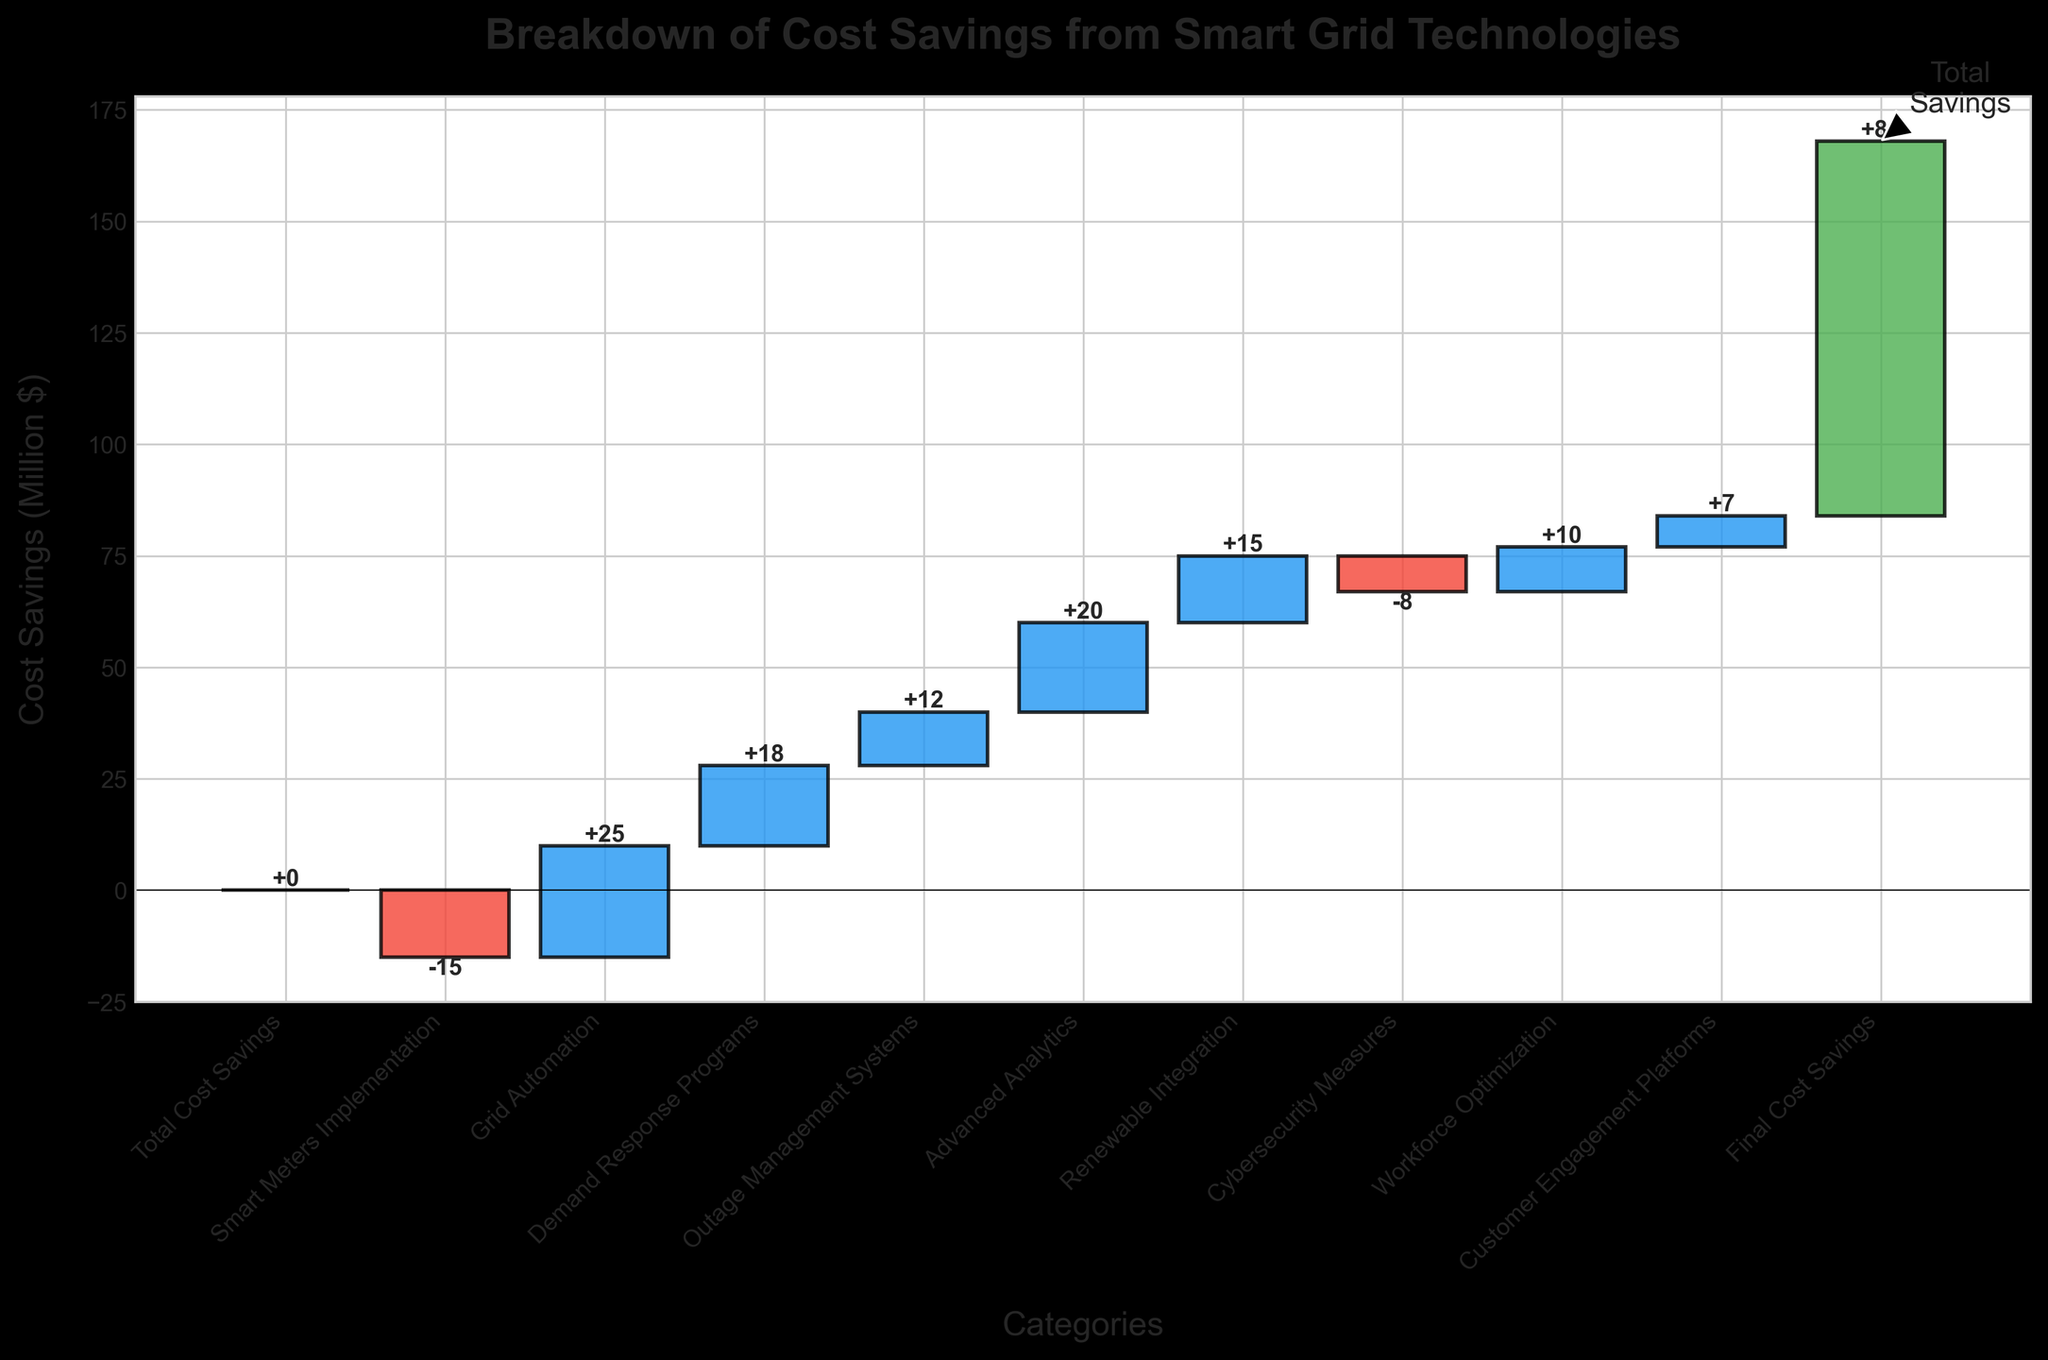What is the title of the chart? The title of the chart is usually prominently displayed at the top and provides a summary of what the chart is about. Here, it's written in bold and larger font size.
Answer: Breakdown of Cost Savings from Smart Grid Technologies How many categories are shown in the chart, including the total and final cost savings? Count the number of labels on the x-axis. Each label represents a different category.
Answer: 10 Which category contributes the most to the cost savings? Identify the category with the tallest blue bar, which indicates a positive value. The height corresponds to the largest positive contribution to cost savings.
Answer: Grid Automation Which category results in the largest increase in cost? Look for the category with the tallest red bar. Red bars indicate a negative value, which means an increase in costs instead of savings.
Answer: Smart Meters Implementation What are the values of cost savings from Grid Automation and Advanced Analytics combined? Add the values of the cost savings from the Grid Automation category (25) and Advanced Analytics category (20). 25 + 20 = 45
Answer: 45 What is the sum of cost savings from Demand Response Programs, Outage Management Systems, and Renewable Integration? Add the values from these categories: Demand Response Programs (18), Outage Management Systems (12), and Renewable Integration (15). 18 + 12 + 15 = 45
Answer: 45 Between Smart Meters Implementation and Cybersecurity Measures, which one had a greater negative impact on cost savings? Compare the absolute values of the negative contributions. Smart Meters Implementation has -15, and Cybersecurity Measures has -8. The higher negative number indicates a greater impact.
Answer: Smart Meters Implementation What is the final cost savings achieved after implementing all the smart grid technologies? Look at the value represented by the final green bar at the end. This bar represents the net savings after considering all the positive and negative contributions.
Answer: 84 How much did Customer Engagement Platforms contribute to the overall cost savings? Refer to the blue bar labeled Customer Engagement Platforms. The height/location on the y-axis indicates this contribution.
Answer: 7 If the value from Workforce Optimization is subtracted from the value of Grid Automation, what is the result? Subtract the value of Workforce Optimization (10) from Grid Automation (25). 25 - 10 = 15
Answer: 15 